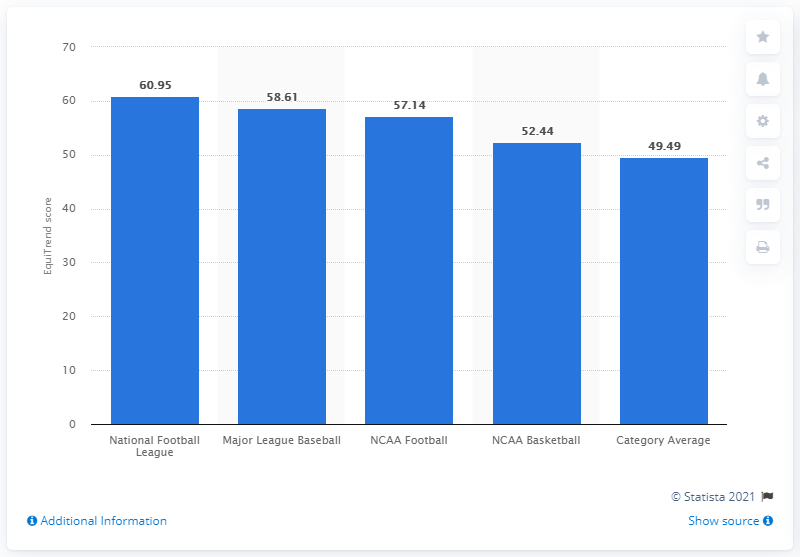Indicate a few pertinent items in this graphic. In 2012, the EquiTrend score of the National Football League was 60.95, indicating a high level of popularity and success for the league that year. In 2012, the brand equity ranking of NCAA Basketball in the US was 52.44, indicating a strong and well-established brand with a high level of recognition and loyalty among consumers. The mean value of all bars is approximately 55.726. 